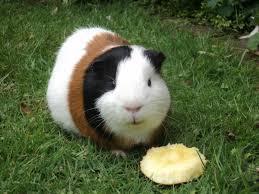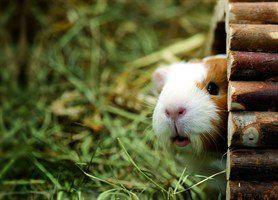The first image is the image on the left, the second image is the image on the right. Considering the images on both sides, is "The left image shows a guinea pig standing on grass near tiny white flowers, and the right image shows one guinea pig with something yellowish in its mouth." valid? Answer yes or no. No. The first image is the image on the left, the second image is the image on the right. Assess this claim about the two images: "One of the images features a guinea pig munching on foliage.". Correct or not? Answer yes or no. No. 